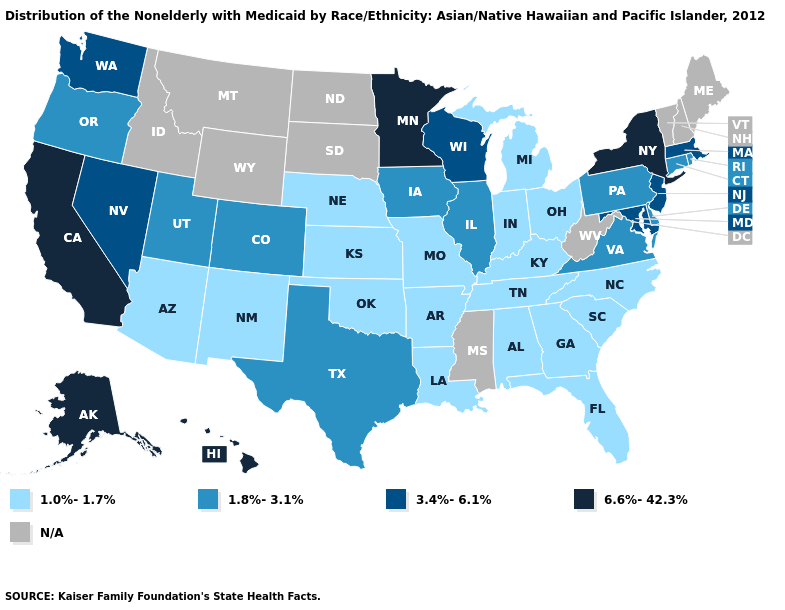What is the highest value in the USA?
Short answer required. 6.6%-42.3%. What is the value of Arizona?
Be succinct. 1.0%-1.7%. What is the value of Illinois?
Be succinct. 1.8%-3.1%. Name the states that have a value in the range 6.6%-42.3%?
Concise answer only. Alaska, California, Hawaii, Minnesota, New York. What is the value of Arizona?
Be succinct. 1.0%-1.7%. What is the value of Mississippi?
Write a very short answer. N/A. Name the states that have a value in the range 1.0%-1.7%?
Keep it brief. Alabama, Arizona, Arkansas, Florida, Georgia, Indiana, Kansas, Kentucky, Louisiana, Michigan, Missouri, Nebraska, New Mexico, North Carolina, Ohio, Oklahoma, South Carolina, Tennessee. Which states have the lowest value in the USA?
Answer briefly. Alabama, Arizona, Arkansas, Florida, Georgia, Indiana, Kansas, Kentucky, Louisiana, Michigan, Missouri, Nebraska, New Mexico, North Carolina, Ohio, Oklahoma, South Carolina, Tennessee. What is the value of Connecticut?
Write a very short answer. 1.8%-3.1%. Does Washington have the lowest value in the West?
Short answer required. No. Among the states that border Ohio , does Pennsylvania have the highest value?
Concise answer only. Yes. What is the value of Tennessee?
Be succinct. 1.0%-1.7%. Does Nevada have the lowest value in the USA?
Short answer required. No. 